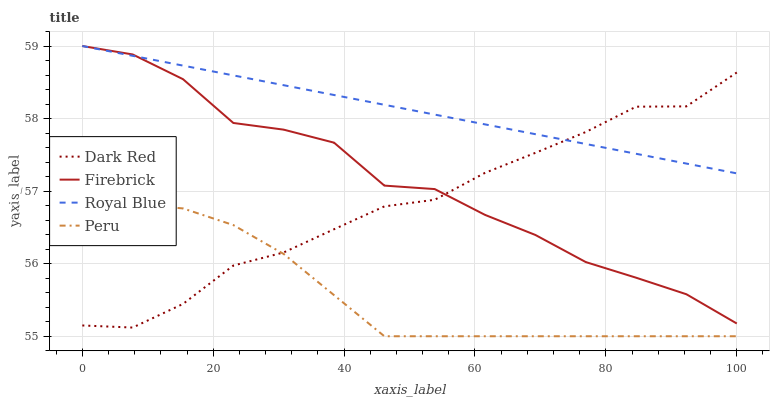Does Peru have the minimum area under the curve?
Answer yes or no. Yes. Does Royal Blue have the maximum area under the curve?
Answer yes or no. Yes. Does Firebrick have the minimum area under the curve?
Answer yes or no. No. Does Firebrick have the maximum area under the curve?
Answer yes or no. No. Is Royal Blue the smoothest?
Answer yes or no. Yes. Is Firebrick the roughest?
Answer yes or no. Yes. Is Peru the smoothest?
Answer yes or no. No. Is Peru the roughest?
Answer yes or no. No. Does Firebrick have the lowest value?
Answer yes or no. No. Does Royal Blue have the highest value?
Answer yes or no. Yes. Does Peru have the highest value?
Answer yes or no. No. Is Peru less than Royal Blue?
Answer yes or no. Yes. Is Firebrick greater than Peru?
Answer yes or no. Yes. Does Peru intersect Dark Red?
Answer yes or no. Yes. Is Peru less than Dark Red?
Answer yes or no. No. Is Peru greater than Dark Red?
Answer yes or no. No. Does Peru intersect Royal Blue?
Answer yes or no. No. 